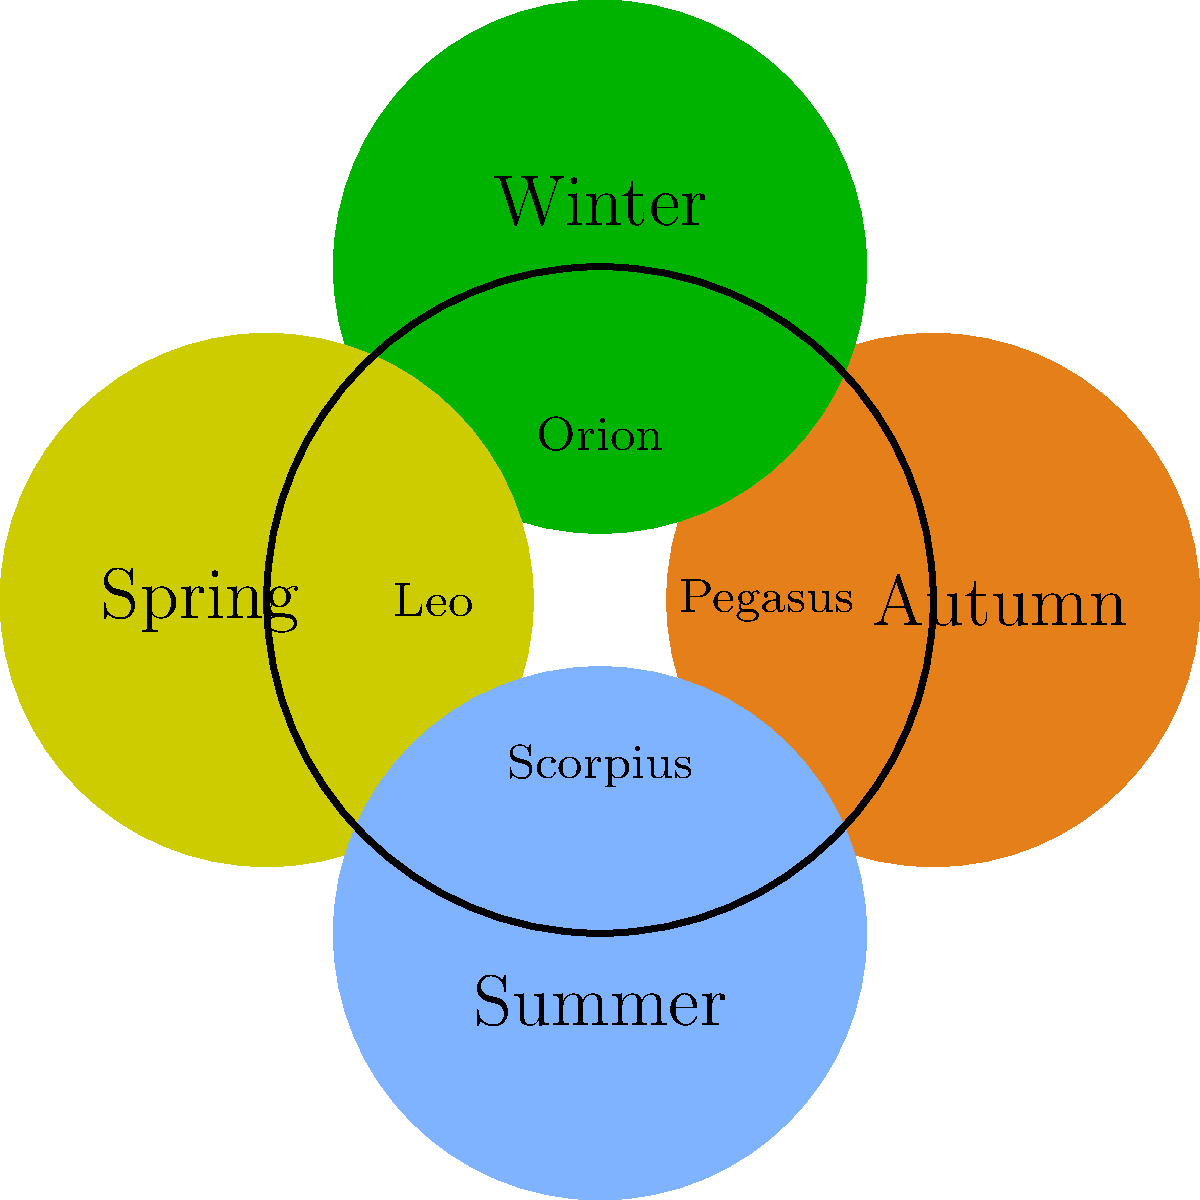As a novel writer exploring celestial themes, you're crafting a story that spans the four seasons. Which constellation, associated with a mythological creature that was slain by Hercules, is prominently visible during summer nights in the Northern Hemisphere? To answer this question, let's break down the information and consider the seasonal visibility of constellations:

1. The question asks about a constellation visible in summer in the Northern Hemisphere.
2. It's associated with a mythological creature slain by Hercules.
3. Looking at the diagram, we see four constellations associated with different seasons:
   - Autumn: Pegasus
   - Winter: Orion
   - Spring: Leo
   - Summer: Scorpius

4. Among these, Scorpius is associated with summer.
5. In Greek mythology, Scorpius (the scorpion) was indeed slain by Hercules:
   - Hercules encountered the giant scorpion during his second labor.
   - The scorpion was sent by Hera to kill Hercules.
   - After a fierce battle, Hercules defeated the scorpion.
   - Zeus placed both Hercules and the scorpion in the sky as constellations.

6. Scorpius is one of the most distinctive constellations in the summer sky, with its curved tail resembling a scorpion's stinger.

Therefore, Scorpius fits all the criteria mentioned in the question: it's visible in summer, associated with a creature slain by Hercules, and has a rich mythological background perfect for a novel writer's narrative.
Answer: Scorpius 